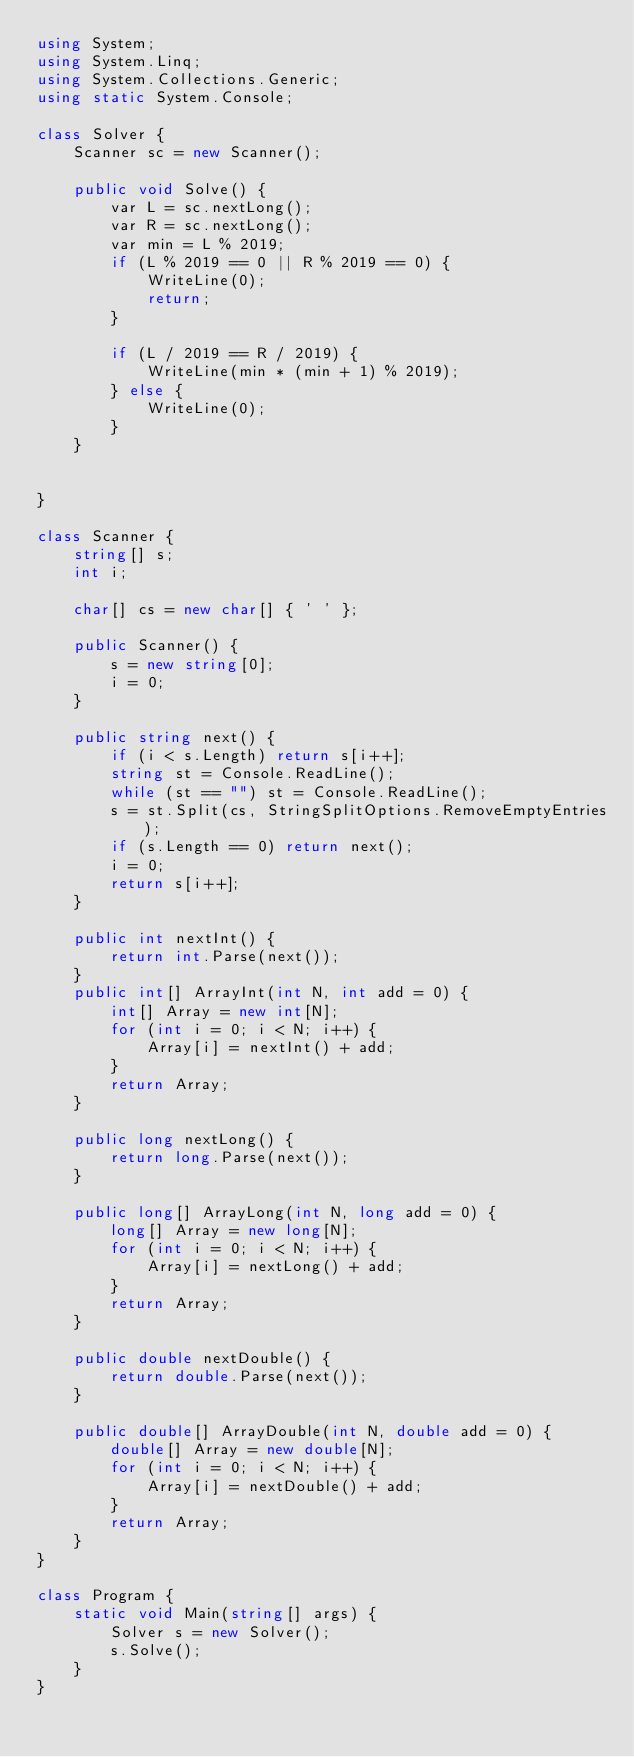<code> <loc_0><loc_0><loc_500><loc_500><_C#_>using System;
using System.Linq;
using System.Collections.Generic;
using static System.Console;

class Solver {
    Scanner sc = new Scanner();

    public void Solve() {
        var L = sc.nextLong();
        var R = sc.nextLong();
        var min = L % 2019;
        if (L % 2019 == 0 || R % 2019 == 0) {
            WriteLine(0);
            return;
        }

        if (L / 2019 == R / 2019) {
            WriteLine(min * (min + 1) % 2019);
        } else {
            WriteLine(0);
        }
    }


}

class Scanner {
    string[] s;
    int i;

    char[] cs = new char[] { ' ' };

    public Scanner() {
        s = new string[0];
        i = 0;
    }

    public string next() {
        if (i < s.Length) return s[i++];
        string st = Console.ReadLine();
        while (st == "") st = Console.ReadLine();
        s = st.Split(cs, StringSplitOptions.RemoveEmptyEntries);
        if (s.Length == 0) return next();
        i = 0;
        return s[i++];
    }

    public int nextInt() {
        return int.Parse(next());
    }
    public int[] ArrayInt(int N, int add = 0) {
        int[] Array = new int[N];
        for (int i = 0; i < N; i++) {
            Array[i] = nextInt() + add;
        }
        return Array;
    }

    public long nextLong() {
        return long.Parse(next());
    }

    public long[] ArrayLong(int N, long add = 0) {
        long[] Array = new long[N];
        for (int i = 0; i < N; i++) {
            Array[i] = nextLong() + add;
        }
        return Array;
    }

    public double nextDouble() {
        return double.Parse(next());
    }

    public double[] ArrayDouble(int N, double add = 0) {
        double[] Array = new double[N];
        for (int i = 0; i < N; i++) {
            Array[i] = nextDouble() + add;
        }
        return Array;
    }
}

class Program {
    static void Main(string[] args) {
        Solver s = new Solver();
        s.Solve();
    }
}
</code> 